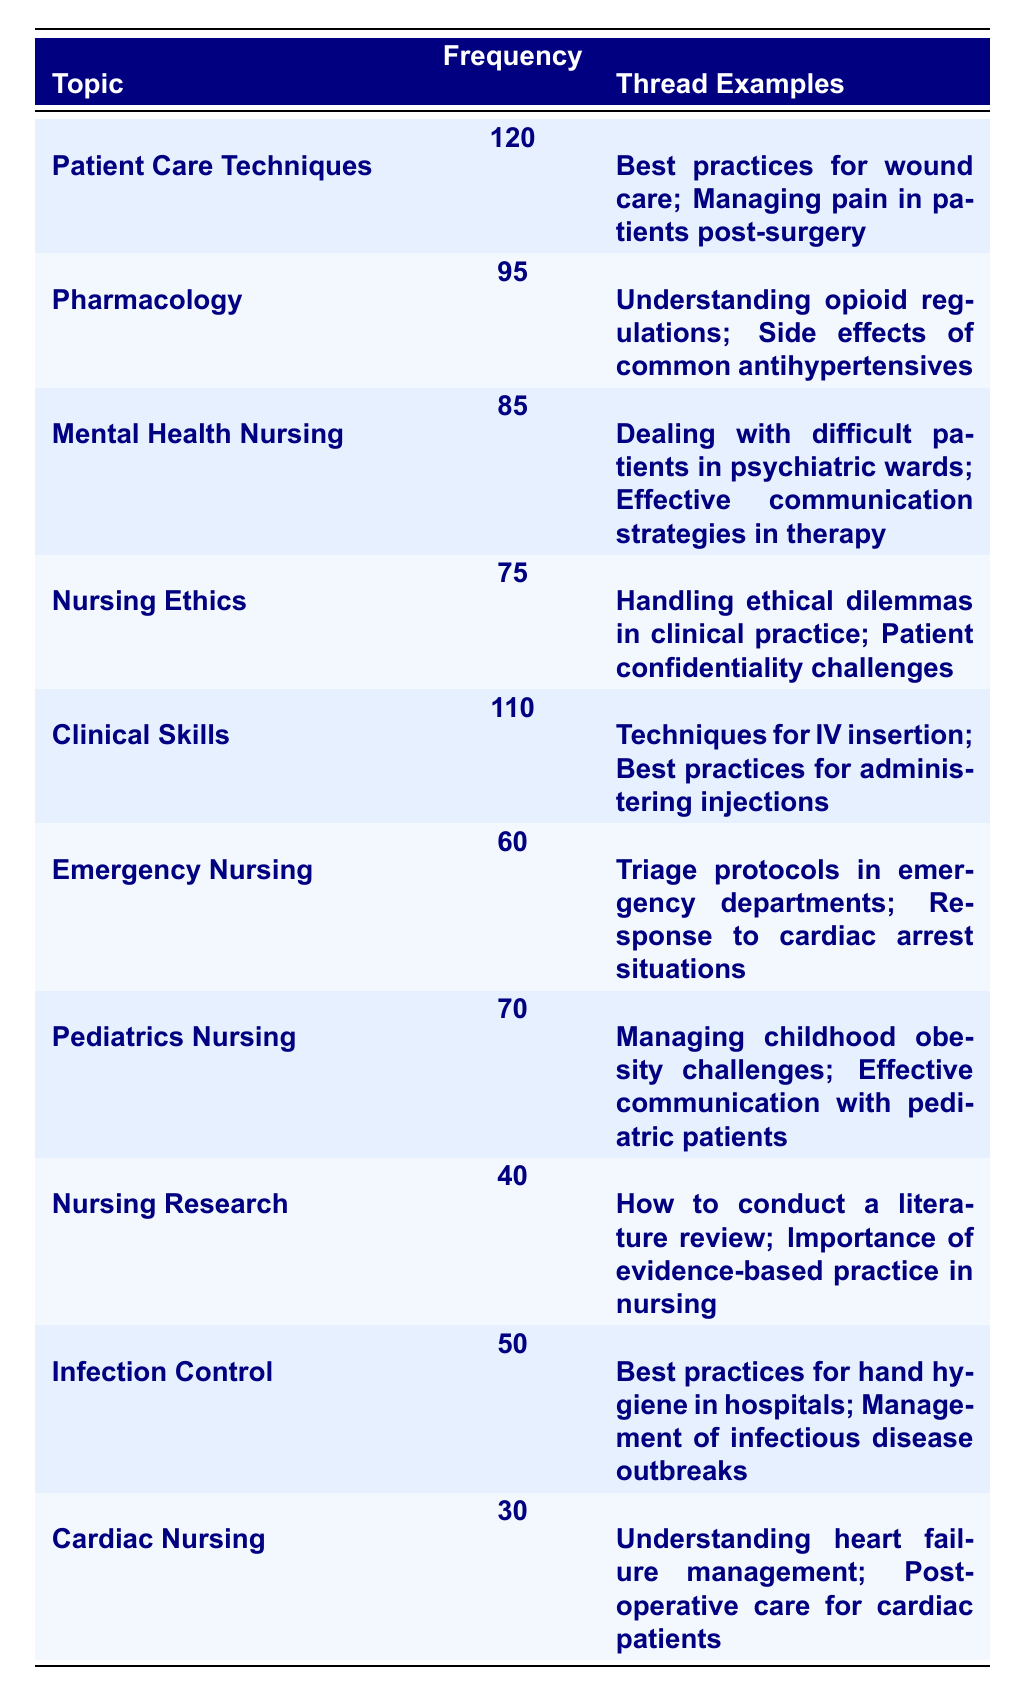What is the most frequently discussed nursing topic in the forum? The table shows that "Patient Care Techniques" has the highest frequency of 120, making it the most frequently discussed topic.
Answer: Patient Care Techniques How many threads were discussed under "Pharmacology"? The frequency under "Pharmacology" is listed as 95, indicating there were 95 threads about this topic.
Answer: 95 Is "Cardiac Nursing" discussed more frequently than "Infection Control"? "Cardiac Nursing" has a frequency of 30, while "Infection Control" has a frequency of 50. Since 30 is less than 50, "Cardiac Nursing" is discussed less frequently.
Answer: No What is the combined frequency of "Mental Health Nursing" and "Nursing Ethics"? The frequency for "Mental Health Nursing" is 85 and for "Nursing Ethics" is 75. Adding these together: 85 + 75 = 160 gives the combined frequency.
Answer: 160 Which topics are discussed more frequently than 70 threads? Referring to the table, "Patient Care Techniques" (120), "Clinical Skills" (110), "Pharmacology" (95), and "Mental Health Nursing" (85) have frequencies greater than 70.
Answer: Patient Care Techniques, Clinical Skills, Pharmacology, Mental Health Nursing What is the total number of threads discussed across all topics? By adding all frequencies: 120 + 95 + 85 + 75 + 110 + 60 + 70 + 40 + 50 + 30 = 795, we find the total number of threads.
Answer: 795 Which topic has the least frequency and what is the frequency? The table indicates "Cardiac Nursing" has the least frequency of 30 threads discussed, making it the least frequent topic.
Answer: 30 What is the difference in frequency between "Emergency Nursing" and "Pediatrics Nursing"? "Emergency Nursing" has a frequency of 60, while "Pediatrics Nursing" has 70. The difference is calculated as 70 - 60 = 10.
Answer: 10 How many nursing topics have a frequency greater than 80? The topics with frequencies greater than 80 are "Patient Care Techniques" (120), "Clinical Skills" (110), "Pharmacology" (95), and "Mental Health Nursing" (85). Counting these gives us 4 topics total.
Answer: 4 Is there a nursing topic with a frequency of 40? Yes, "Nursing Research" has a frequency of 40, which confirms that there is such a topic.
Answer: Yes If you combine the frequency of "Nursing Ethics" and "Emergency Nursing," what is the result? "Nursing Ethics" has a frequency of 75 and "Emergency Nursing" has a frequency of 60. Adding these together gives 75 + 60 = 135.
Answer: 135 